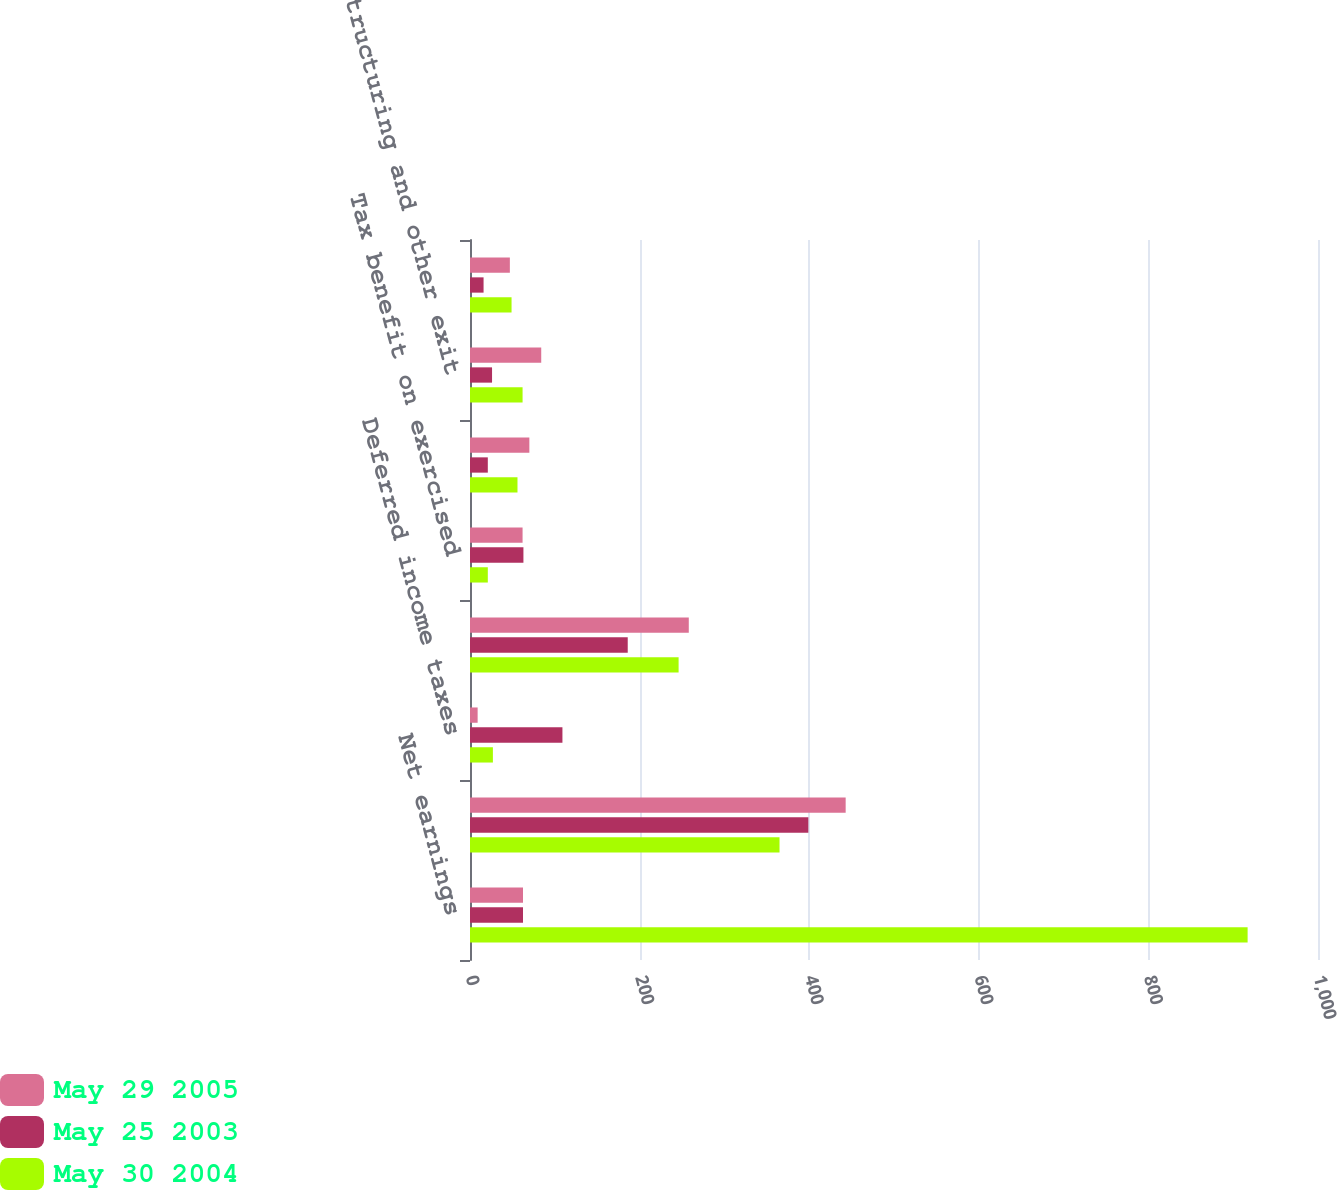Convert chart. <chart><loc_0><loc_0><loc_500><loc_500><stacked_bar_chart><ecel><fcel>Net earnings<fcel>Depreciation and amortization<fcel>Deferred income taxes<fcel>Changes in current assets and<fcel>Tax benefit on exercised<fcel>Pension and other<fcel>Restructuring and other exit<fcel>Other net<nl><fcel>May 29 2005<fcel>62.5<fcel>443<fcel>9<fcel>258<fcel>62<fcel>70<fcel>84<fcel>47<nl><fcel>May 25 2003<fcel>62.5<fcel>399<fcel>109<fcel>186<fcel>63<fcel>21<fcel>26<fcel>16<nl><fcel>May 30 2004<fcel>917<fcel>365<fcel>27<fcel>246<fcel>21<fcel>56<fcel>62<fcel>49<nl></chart> 